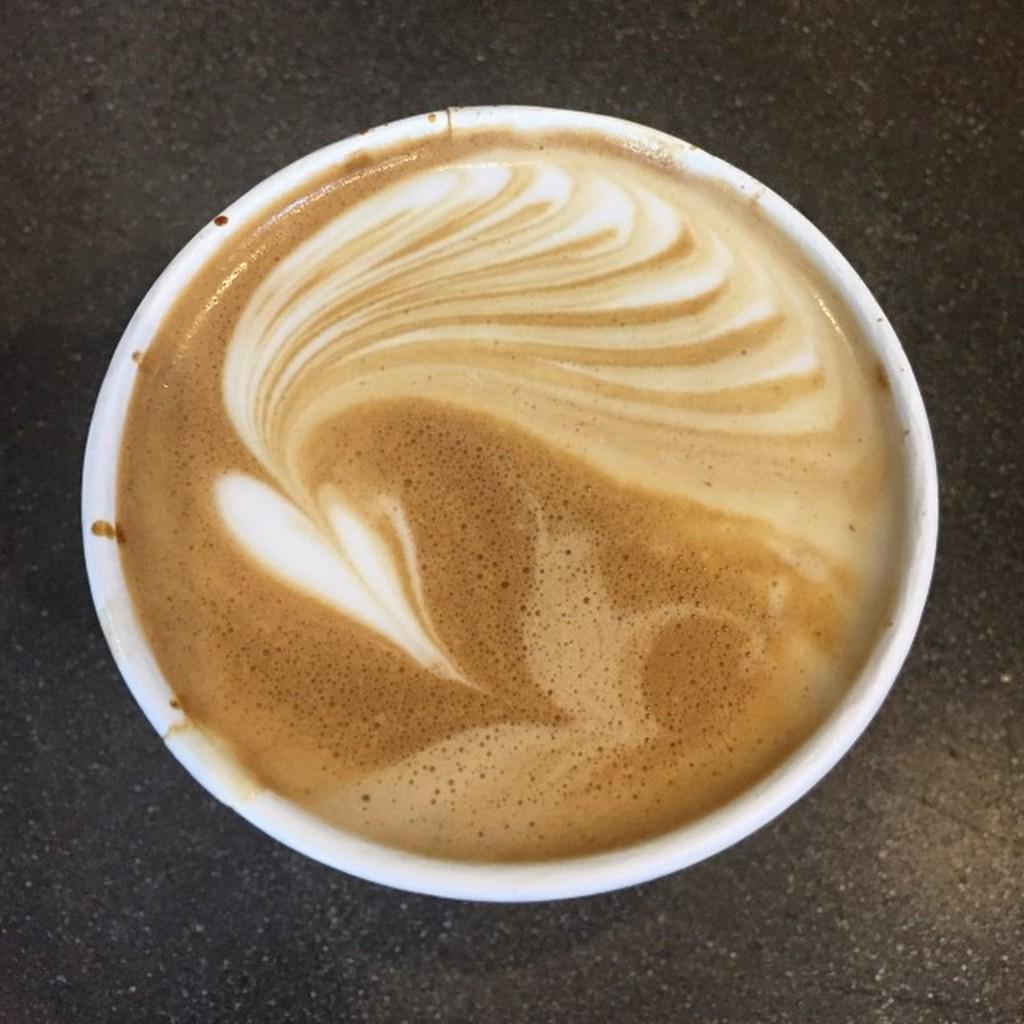What is the main subject in the center of the image? There is a cappuccino in a cup in the center of the image. What is located at the bottom of the image? There is a table at the bottom of the image. What type of quartz can be seen in the image? There is no quartz present in the image. Can you provide an example of a scientific experiment conducted in the image? There is no scientific experiment depicted in the image; it features a cappuccino in a cup and a table. 